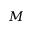<formula> <loc_0><loc_0><loc_500><loc_500>M</formula> 